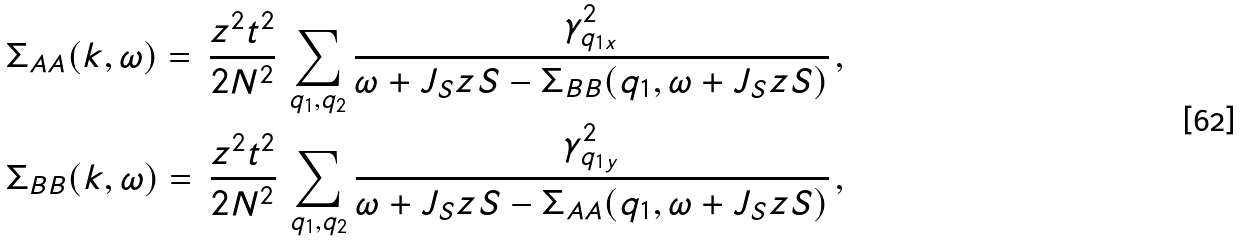Convert formula to latex. <formula><loc_0><loc_0><loc_500><loc_500>& \Sigma _ { A A } ( { k } , \omega ) = \, \frac { z ^ { 2 } t ^ { 2 } } { 2 N ^ { 2 } } \, \sum _ { q _ { 1 } , q _ { 2 } } \frac { \gamma ^ { 2 } _ { q _ { 1 x } } } { \omega + J _ { S } z S - \Sigma _ { B B } ( { q } _ { 1 } , \omega + J _ { S } z S ) } \, , \\ & \Sigma _ { B B } ( { k } , \omega ) = \, \frac { z ^ { 2 } t ^ { 2 } } { 2 N ^ { 2 } } \, \sum _ { q _ { 1 } , q _ { 2 } } \frac { \gamma ^ { 2 } _ { q _ { 1 y } } } { \omega + J _ { S } z S - \Sigma _ { A A } ( { q } _ { 1 } , \omega + J _ { S } z S ) } \, ,</formula> 